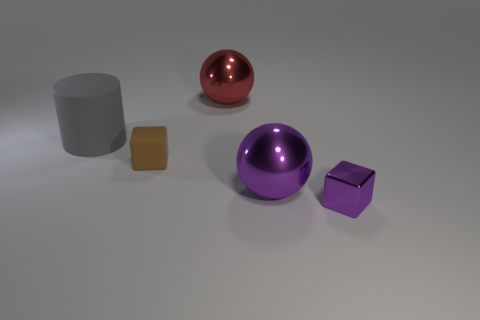There is another small thing that is the same shape as the small shiny thing; what color is it?
Make the answer very short. Brown. Is there anything else that is the same shape as the big red metallic thing?
Your answer should be compact. Yes. How many other things are the same shape as the brown rubber thing?
Offer a terse response. 1. There is a shiny sphere in front of the big gray cylinder that is on the left side of the large thing that is in front of the gray thing; what is its color?
Provide a succinct answer. Purple. Is the number of tiny purple shiny cubes behind the big matte object less than the number of brown matte objects?
Make the answer very short. Yes. Do the small object on the right side of the big red metallic sphere and the big object that is on the left side of the red shiny thing have the same shape?
Your response must be concise. No. What number of objects are either things that are on the right side of the large gray matte thing or large cylinders?
Provide a succinct answer. 5. What is the material of the large thing that is the same color as the metallic cube?
Provide a succinct answer. Metal. There is a purple shiny thing left of the small object to the right of the red metal sphere; are there any gray rubber things that are in front of it?
Your answer should be compact. No. Are there fewer small rubber cubes that are behind the large red thing than purple spheres that are on the left side of the tiny rubber block?
Offer a terse response. No. 